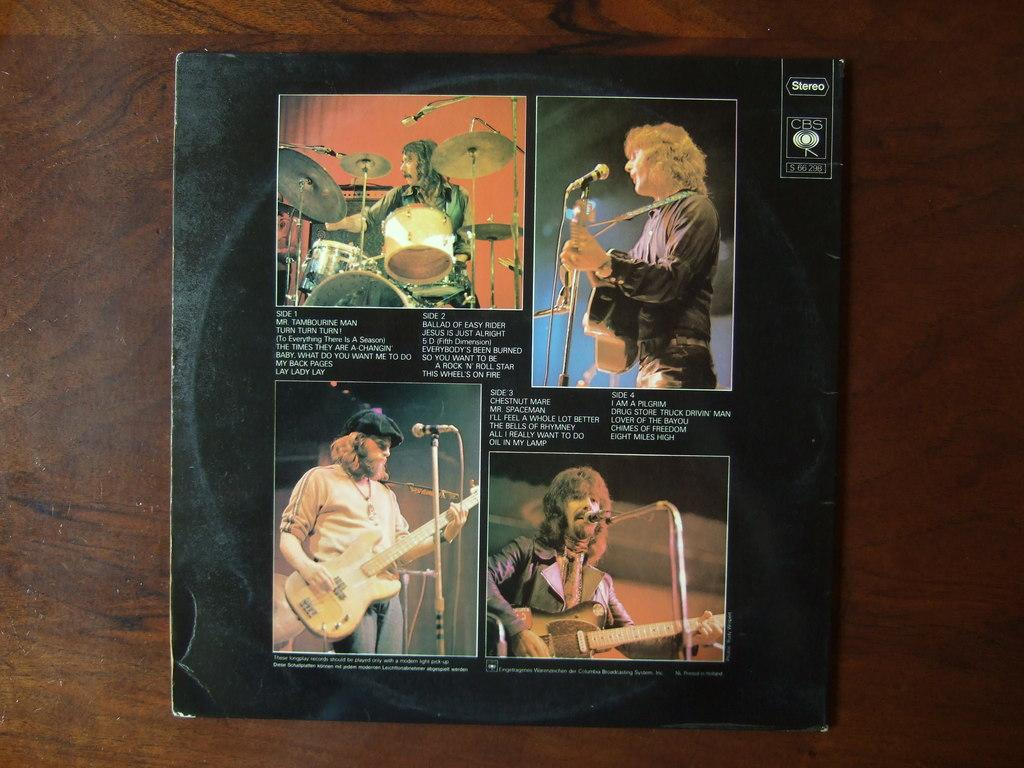Provide a one-sentence caption for the provided image. Mr. Tambourine Man is the first song shown on this CD cover. 